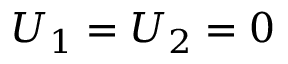Convert formula to latex. <formula><loc_0><loc_0><loc_500><loc_500>U _ { 1 } = U _ { 2 } = 0</formula> 